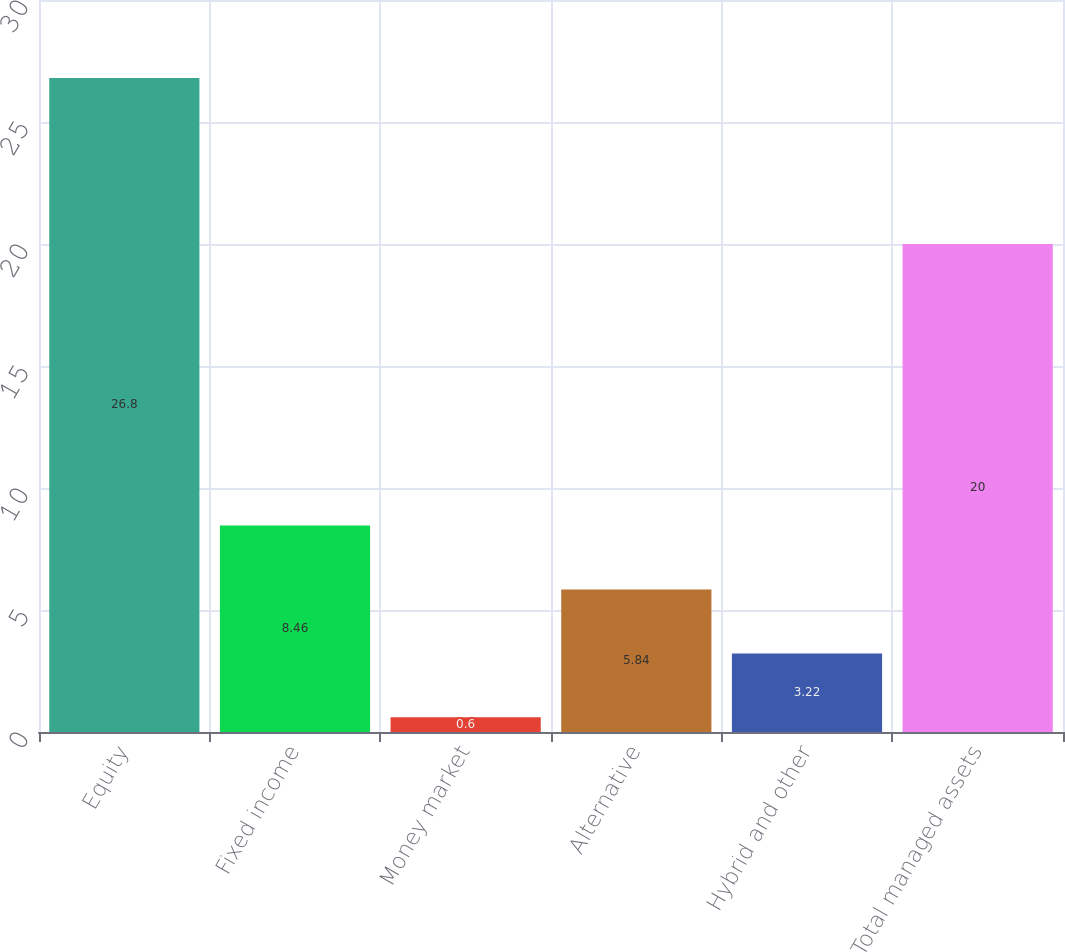Convert chart. <chart><loc_0><loc_0><loc_500><loc_500><bar_chart><fcel>Equity<fcel>Fixed income<fcel>Money market<fcel>Alternative<fcel>Hybrid and other<fcel>Total managed assets<nl><fcel>26.8<fcel>8.46<fcel>0.6<fcel>5.84<fcel>3.22<fcel>20<nl></chart> 